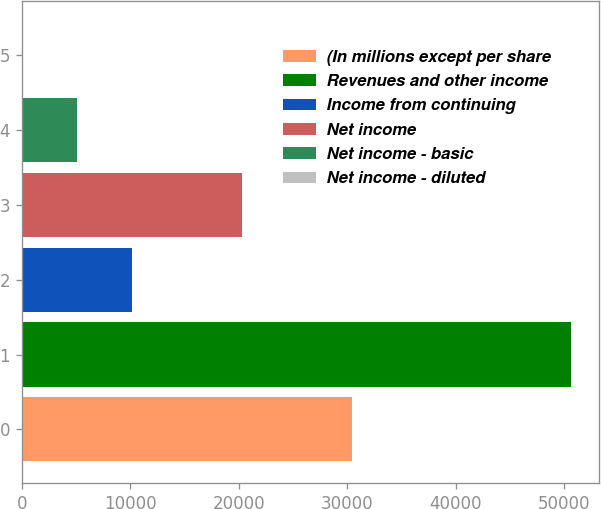Convert chart to OTSL. <chart><loc_0><loc_0><loc_500><loc_500><bar_chart><fcel>(In millions except per share<fcel>Revenues and other income<fcel>Income from continuing<fcel>Net income<fcel>Net income - basic<fcel>Net income - diluted<nl><fcel>30403.8<fcel>50670<fcel>10137.5<fcel>20270.6<fcel>5070.95<fcel>4.39<nl></chart> 